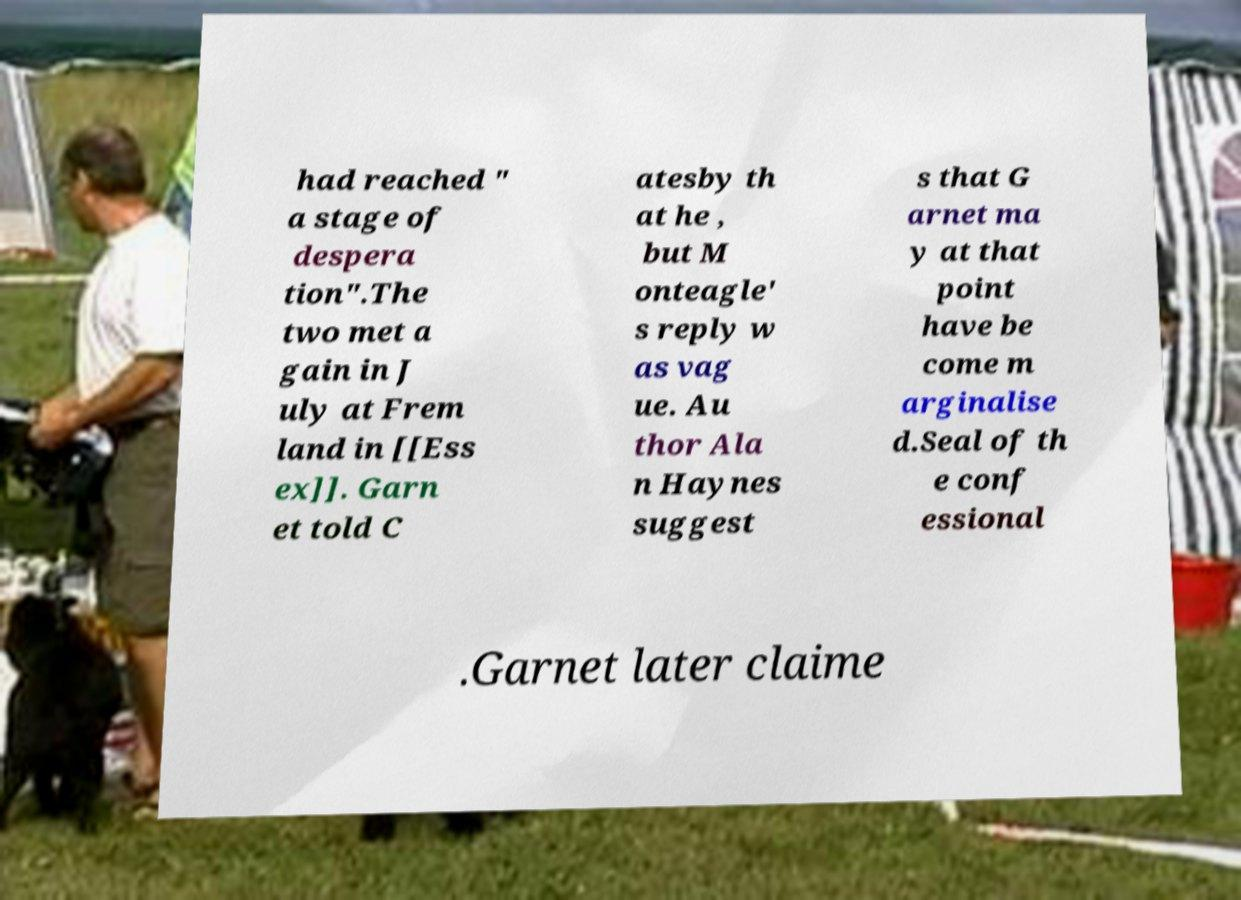There's text embedded in this image that I need extracted. Can you transcribe it verbatim? had reached " a stage of despera tion".The two met a gain in J uly at Frem land in [[Ess ex]]. Garn et told C atesby th at he , but M onteagle' s reply w as vag ue. Au thor Ala n Haynes suggest s that G arnet ma y at that point have be come m arginalise d.Seal of th e conf essional .Garnet later claime 